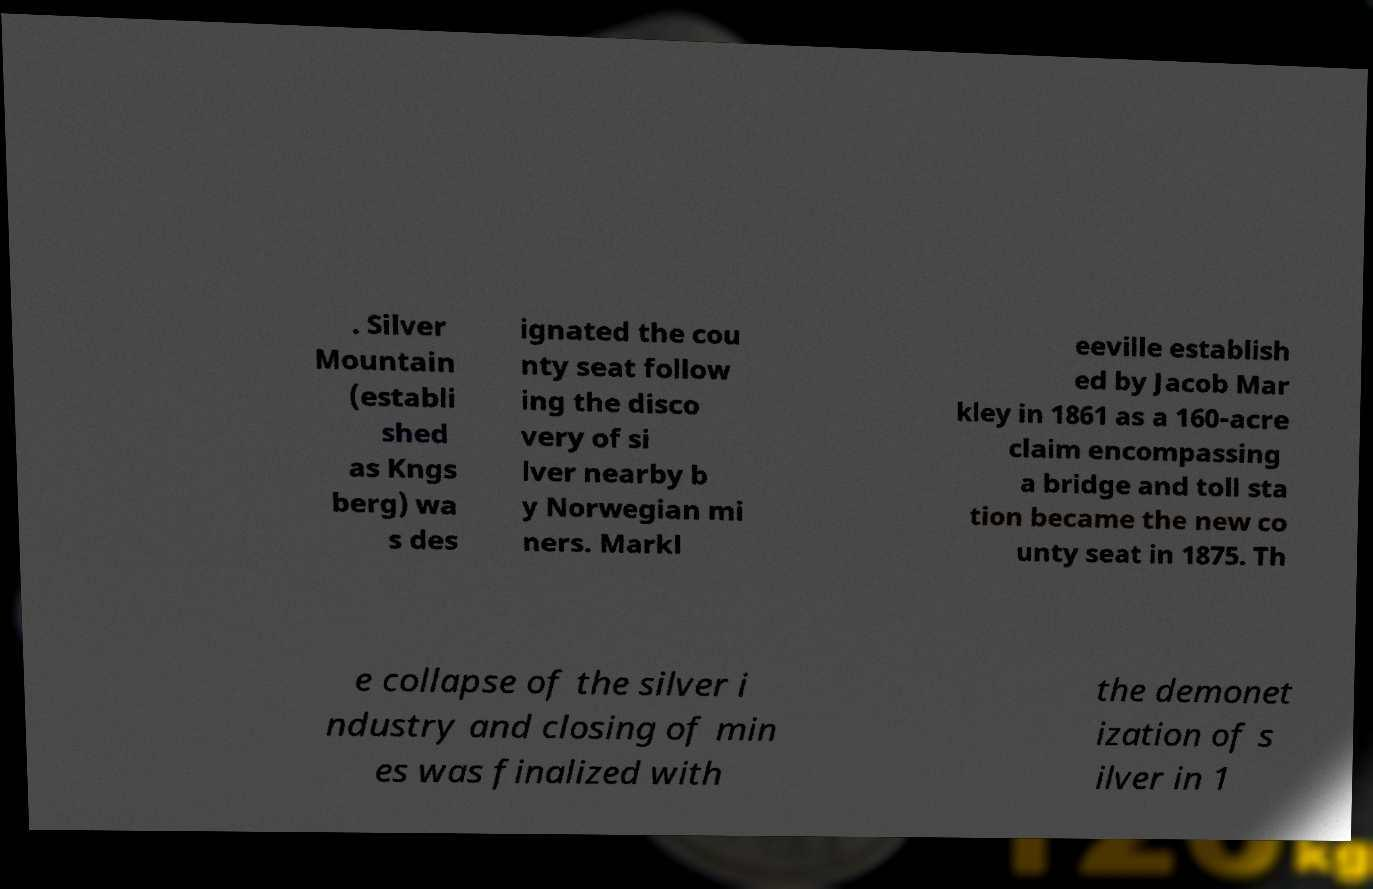Please identify and transcribe the text found in this image. . Silver Mountain (establi shed as Kngs berg) wa s des ignated the cou nty seat follow ing the disco very of si lver nearby b y Norwegian mi ners. Markl eeville establish ed by Jacob Mar kley in 1861 as a 160-acre claim encompassing a bridge and toll sta tion became the new co unty seat in 1875. Th e collapse of the silver i ndustry and closing of min es was finalized with the demonet ization of s ilver in 1 